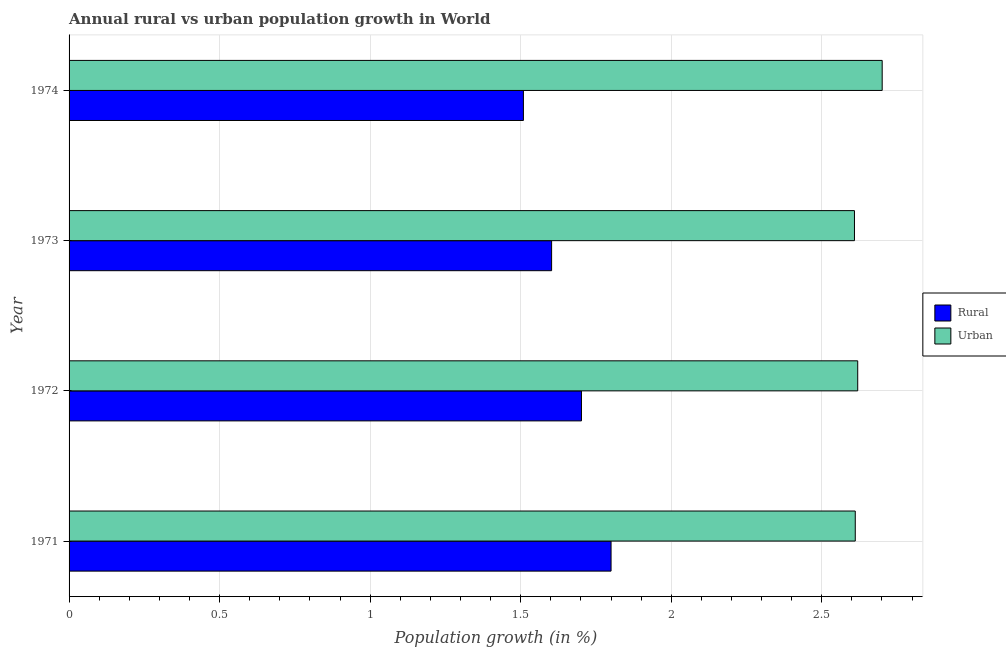How many different coloured bars are there?
Offer a terse response. 2. Are the number of bars per tick equal to the number of legend labels?
Offer a terse response. Yes. Are the number of bars on each tick of the Y-axis equal?
Offer a very short reply. Yes. How many bars are there on the 2nd tick from the top?
Your answer should be very brief. 2. How many bars are there on the 3rd tick from the bottom?
Make the answer very short. 2. In how many cases, is the number of bars for a given year not equal to the number of legend labels?
Offer a very short reply. 0. What is the urban population growth in 1973?
Make the answer very short. 2.61. Across all years, what is the maximum urban population growth?
Your answer should be very brief. 2.7. Across all years, what is the minimum rural population growth?
Give a very brief answer. 1.51. In which year was the rural population growth minimum?
Offer a very short reply. 1974. What is the total urban population growth in the graph?
Your answer should be compact. 10.54. What is the difference between the urban population growth in 1971 and that in 1973?
Your answer should be compact. 0. What is the difference between the rural population growth in 1972 and the urban population growth in 1973?
Ensure brevity in your answer.  -0.91. What is the average urban population growth per year?
Ensure brevity in your answer.  2.63. In the year 1971, what is the difference between the urban population growth and rural population growth?
Keep it short and to the point. 0.81. In how many years, is the urban population growth greater than 2.3 %?
Offer a very short reply. 4. What is the ratio of the rural population growth in 1972 to that in 1974?
Provide a succinct answer. 1.13. Is the difference between the rural population growth in 1971 and 1973 greater than the difference between the urban population growth in 1971 and 1973?
Offer a very short reply. Yes. What is the difference between the highest and the second highest urban population growth?
Give a very brief answer. 0.08. What is the difference between the highest and the lowest rural population growth?
Offer a terse response. 0.29. In how many years, is the urban population growth greater than the average urban population growth taken over all years?
Your answer should be very brief. 1. What does the 1st bar from the top in 1971 represents?
Give a very brief answer. Urban . What does the 2nd bar from the bottom in 1973 represents?
Provide a short and direct response. Urban . How many bars are there?
Ensure brevity in your answer.  8. How many years are there in the graph?
Provide a succinct answer. 4. Does the graph contain grids?
Your response must be concise. Yes. Where does the legend appear in the graph?
Make the answer very short. Center right. How many legend labels are there?
Give a very brief answer. 2. What is the title of the graph?
Give a very brief answer. Annual rural vs urban population growth in World. Does "Secondary education" appear as one of the legend labels in the graph?
Make the answer very short. No. What is the label or title of the X-axis?
Provide a succinct answer. Population growth (in %). What is the Population growth (in %) of Rural in 1971?
Your response must be concise. 1.8. What is the Population growth (in %) in Urban  in 1971?
Provide a short and direct response. 2.61. What is the Population growth (in %) in Rural in 1972?
Your response must be concise. 1.7. What is the Population growth (in %) in Urban  in 1972?
Keep it short and to the point. 2.62. What is the Population growth (in %) in Rural in 1973?
Your answer should be very brief. 1.6. What is the Population growth (in %) of Urban  in 1973?
Ensure brevity in your answer.  2.61. What is the Population growth (in %) of Rural in 1974?
Offer a terse response. 1.51. What is the Population growth (in %) of Urban  in 1974?
Provide a short and direct response. 2.7. Across all years, what is the maximum Population growth (in %) in Rural?
Your answer should be compact. 1.8. Across all years, what is the maximum Population growth (in %) of Urban ?
Your answer should be compact. 2.7. Across all years, what is the minimum Population growth (in %) of Rural?
Your response must be concise. 1.51. Across all years, what is the minimum Population growth (in %) of Urban ?
Give a very brief answer. 2.61. What is the total Population growth (in %) in Rural in the graph?
Keep it short and to the point. 6.61. What is the total Population growth (in %) in Urban  in the graph?
Offer a terse response. 10.54. What is the difference between the Population growth (in %) in Rural in 1971 and that in 1972?
Give a very brief answer. 0.1. What is the difference between the Population growth (in %) in Urban  in 1971 and that in 1972?
Provide a succinct answer. -0.01. What is the difference between the Population growth (in %) of Rural in 1971 and that in 1973?
Your answer should be compact. 0.2. What is the difference between the Population growth (in %) of Urban  in 1971 and that in 1973?
Keep it short and to the point. 0. What is the difference between the Population growth (in %) in Rural in 1971 and that in 1974?
Provide a short and direct response. 0.29. What is the difference between the Population growth (in %) of Urban  in 1971 and that in 1974?
Ensure brevity in your answer.  -0.09. What is the difference between the Population growth (in %) of Rural in 1972 and that in 1973?
Offer a terse response. 0.1. What is the difference between the Population growth (in %) in Urban  in 1972 and that in 1973?
Provide a short and direct response. 0.01. What is the difference between the Population growth (in %) of Rural in 1972 and that in 1974?
Your answer should be compact. 0.19. What is the difference between the Population growth (in %) of Urban  in 1972 and that in 1974?
Make the answer very short. -0.08. What is the difference between the Population growth (in %) of Rural in 1973 and that in 1974?
Offer a very short reply. 0.09. What is the difference between the Population growth (in %) of Urban  in 1973 and that in 1974?
Keep it short and to the point. -0.09. What is the difference between the Population growth (in %) in Rural in 1971 and the Population growth (in %) in Urban  in 1972?
Your answer should be compact. -0.82. What is the difference between the Population growth (in %) in Rural in 1971 and the Population growth (in %) in Urban  in 1973?
Ensure brevity in your answer.  -0.81. What is the difference between the Population growth (in %) of Rural in 1971 and the Population growth (in %) of Urban  in 1974?
Give a very brief answer. -0.9. What is the difference between the Population growth (in %) of Rural in 1972 and the Population growth (in %) of Urban  in 1973?
Ensure brevity in your answer.  -0.91. What is the difference between the Population growth (in %) in Rural in 1972 and the Population growth (in %) in Urban  in 1974?
Your response must be concise. -1. What is the difference between the Population growth (in %) in Rural in 1973 and the Population growth (in %) in Urban  in 1974?
Your answer should be compact. -1.1. What is the average Population growth (in %) of Rural per year?
Ensure brevity in your answer.  1.65. What is the average Population growth (in %) in Urban  per year?
Offer a terse response. 2.64. In the year 1971, what is the difference between the Population growth (in %) in Rural and Population growth (in %) in Urban ?
Give a very brief answer. -0.81. In the year 1972, what is the difference between the Population growth (in %) in Rural and Population growth (in %) in Urban ?
Ensure brevity in your answer.  -0.92. In the year 1973, what is the difference between the Population growth (in %) of Rural and Population growth (in %) of Urban ?
Your answer should be very brief. -1.01. In the year 1974, what is the difference between the Population growth (in %) in Rural and Population growth (in %) in Urban ?
Give a very brief answer. -1.19. What is the ratio of the Population growth (in %) of Rural in 1971 to that in 1972?
Ensure brevity in your answer.  1.06. What is the ratio of the Population growth (in %) of Rural in 1971 to that in 1973?
Make the answer very short. 1.12. What is the ratio of the Population growth (in %) of Urban  in 1971 to that in 1973?
Keep it short and to the point. 1. What is the ratio of the Population growth (in %) of Rural in 1971 to that in 1974?
Your answer should be very brief. 1.19. What is the ratio of the Population growth (in %) of Urban  in 1971 to that in 1974?
Your response must be concise. 0.97. What is the ratio of the Population growth (in %) of Rural in 1972 to that in 1973?
Offer a terse response. 1.06. What is the ratio of the Population growth (in %) in Rural in 1972 to that in 1974?
Your answer should be very brief. 1.13. What is the ratio of the Population growth (in %) in Urban  in 1972 to that in 1974?
Your response must be concise. 0.97. What is the ratio of the Population growth (in %) of Rural in 1973 to that in 1974?
Offer a very short reply. 1.06. What is the ratio of the Population growth (in %) of Urban  in 1973 to that in 1974?
Offer a terse response. 0.97. What is the difference between the highest and the second highest Population growth (in %) of Rural?
Provide a short and direct response. 0.1. What is the difference between the highest and the second highest Population growth (in %) of Urban ?
Keep it short and to the point. 0.08. What is the difference between the highest and the lowest Population growth (in %) in Rural?
Make the answer very short. 0.29. What is the difference between the highest and the lowest Population growth (in %) in Urban ?
Offer a terse response. 0.09. 